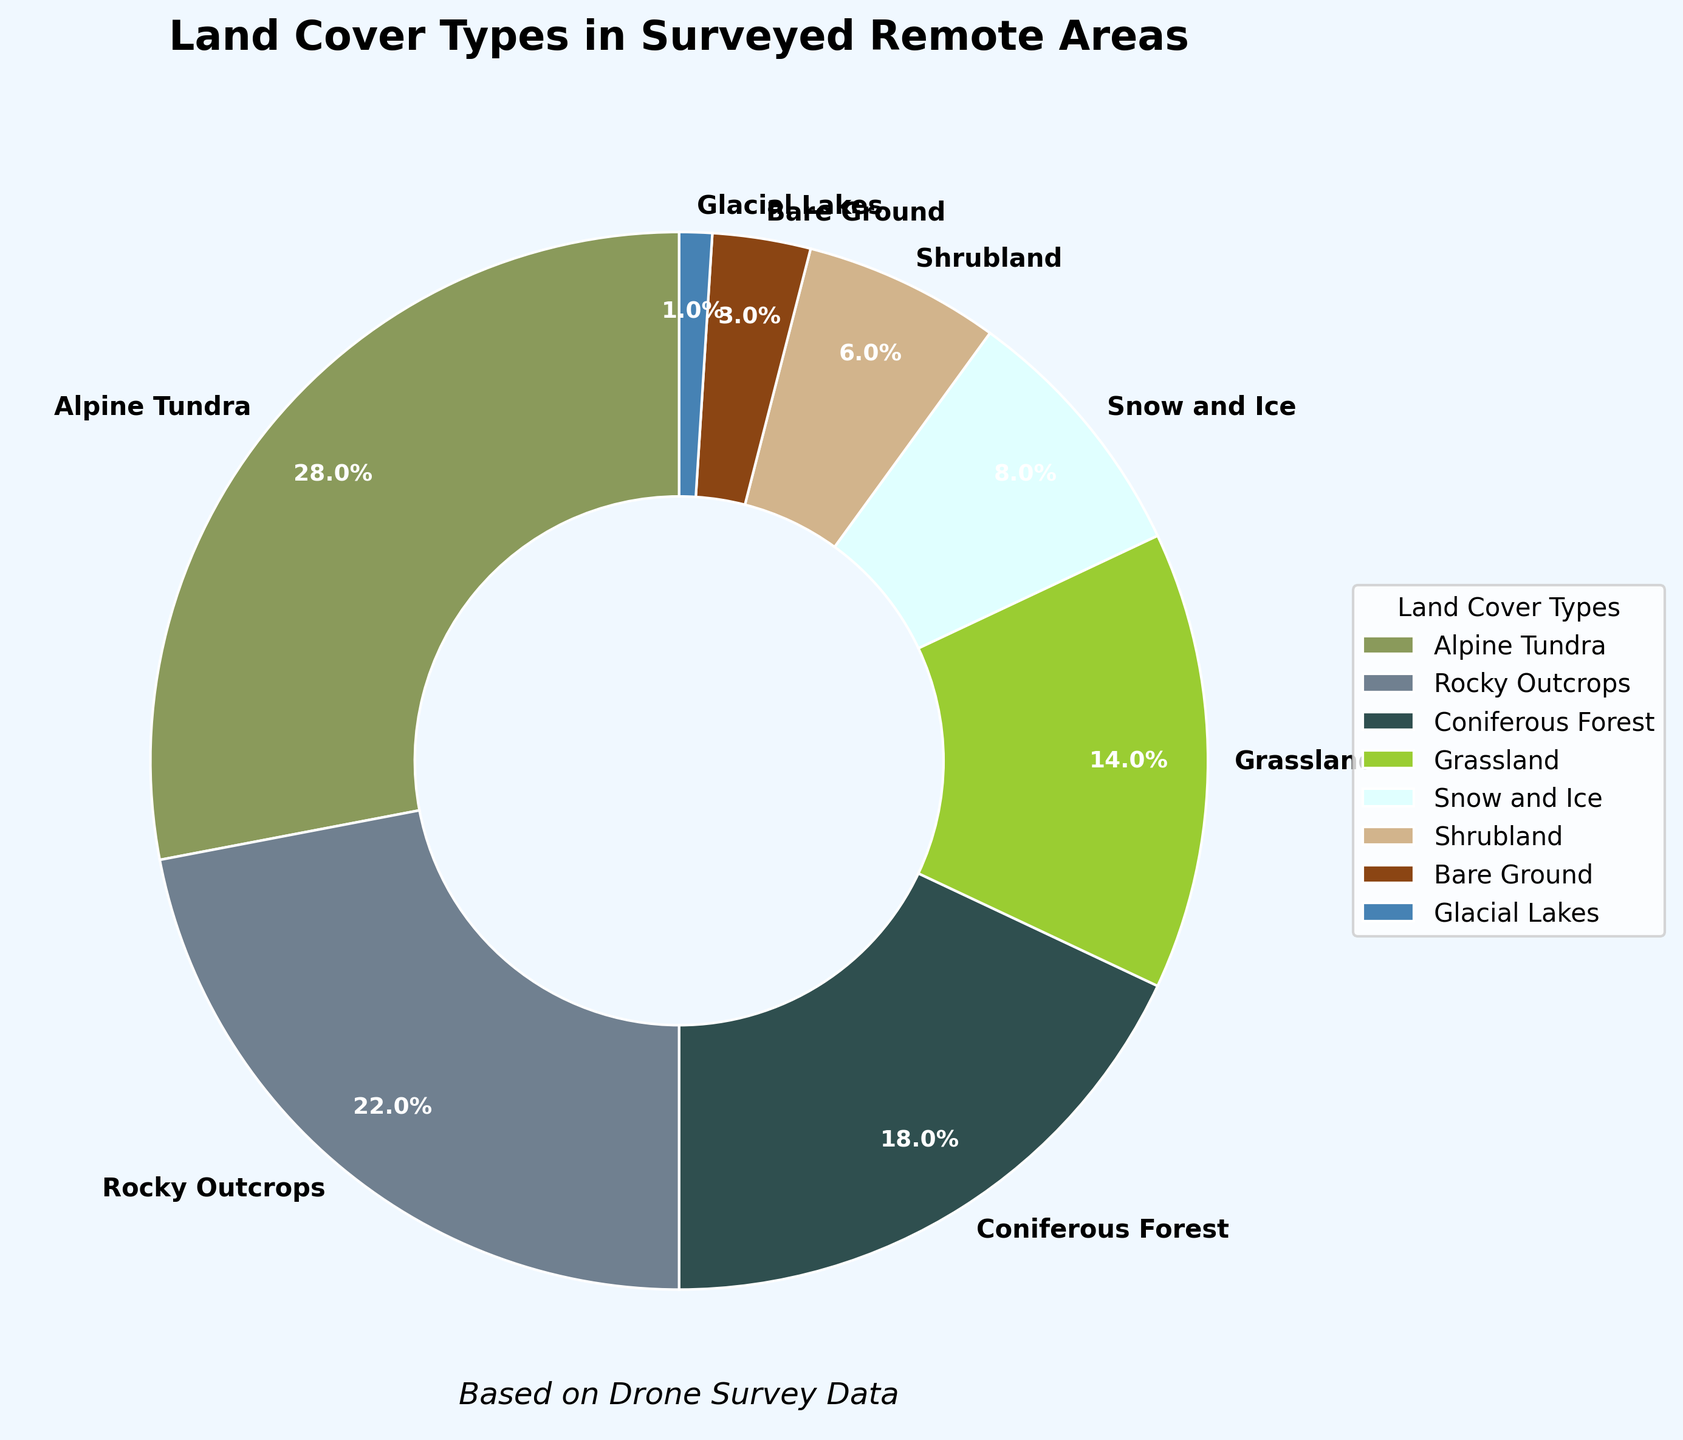Which land cover type has the highest proportion? The Alpine Tundra segment occupies the largest portion of the pie chart. By looking at the labelled proportions, it is 28%.
Answer: Alpine Tundra What is the combined percentage of Alpine Tundra and Rocky Outcrops? Add the percentage of Alpine Tundra (28%) and Rocky Outcrops (22%) together: 28% + 22% = 50%.
Answer: 50% Which two land cover types have the smallest proportions? By examining the smallest slices on the pie chart, Glacial Lakes and Bare Ground have the smallest proportions with 1% and 3%, respectively.
Answer: Glacial Lakes and Bare Ground Is the percentage of Grassland greater than Coniferous Forest? Check the percentages given in the labels. Grassland is 14% and Coniferous Forest is 18%. Since 14% is less than 18%, Grassland has a smaller percentage than Coniferous Forest.
Answer: No What is the difference between the proportion of Coniferous Forest and Shrubland? Subtract the percentage of Shrubland (6%) from the percentage of Coniferous Forest (18%): 18% - 6% = 12%.
Answer: 12% What percentage of the surveyed area is covered by Grassland and Snow and Ice combined? Sum the percentages of Grassland (14%) and Snow and Ice (8%): 14% + 8% = 22%.
Answer: 22% How much larger is the percentage of Alpine Tundra compared to Bare Ground? Subtract the percentage of Bare Ground (3%) from Alpine Tundra (28%): 28% - 3% = 25%.
Answer: 25% Which color represents the Coniferous Forest land cover type? The Coniferous Forest segment is represented by a dark green color in the pie chart.
Answer: Dark green 